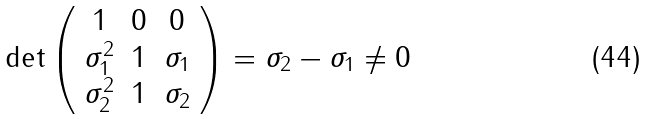Convert formula to latex. <formula><loc_0><loc_0><loc_500><loc_500>\det \left ( \begin{array} { c c c } 1 & 0 & 0 \\ \sigma _ { 1 } ^ { 2 } & 1 & \sigma _ { 1 } \\ \sigma _ { 2 } ^ { 2 } & 1 & \sigma _ { 2 } \end{array} \right ) = \sigma _ { 2 } - \sigma _ { 1 } \neq 0</formula> 